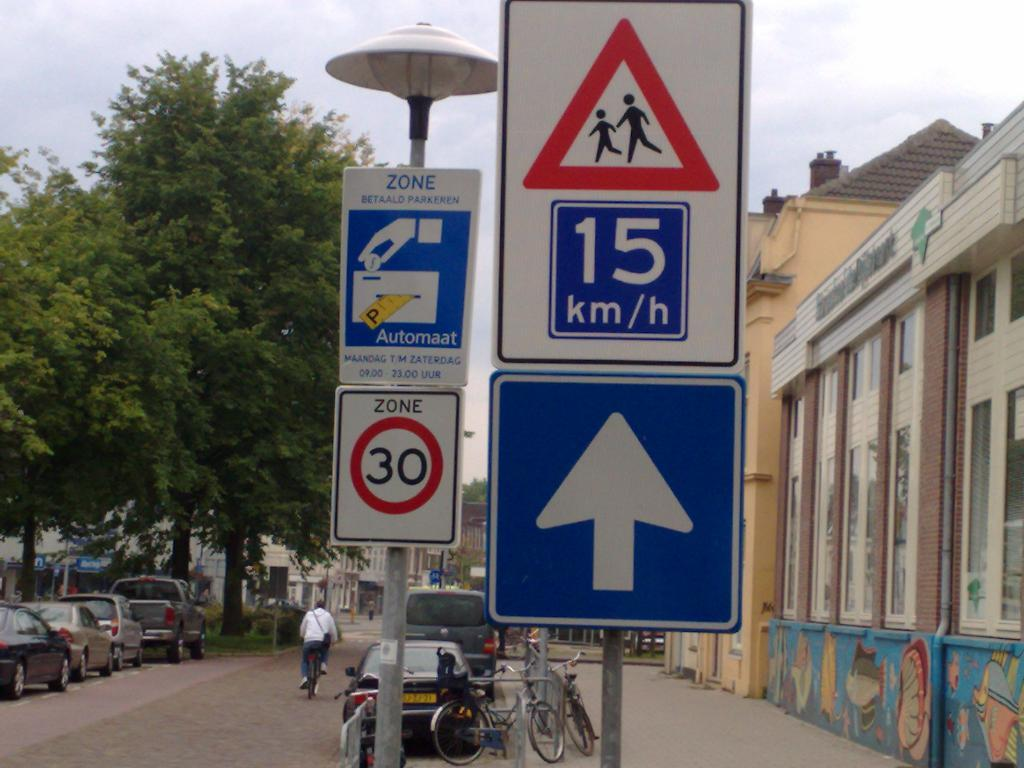<image>
Summarize the visual content of the image. the number 15 is on the sign outside 